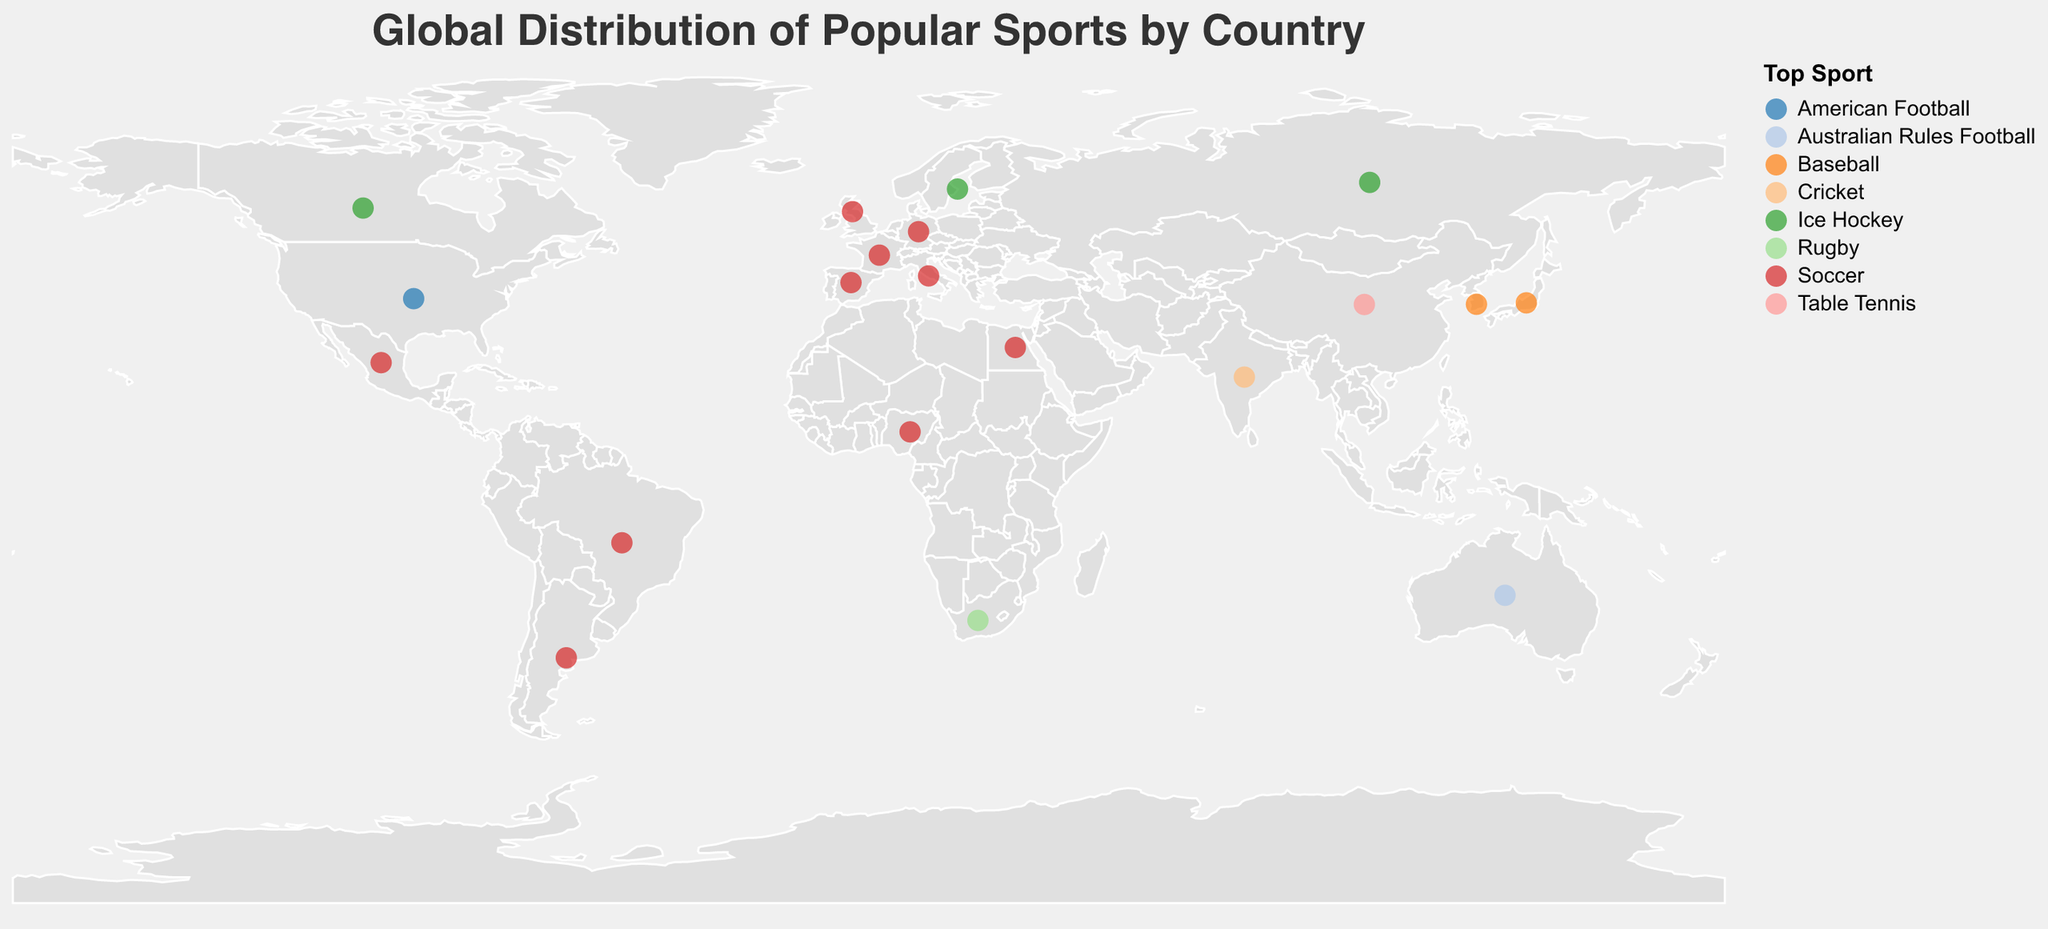Which country has Soccer listed as its top sport? Soccer being the top sport corresponds to countries with circles colored the same specific way. By hovering over the circles, we can identify these countries based on the tooltips.
Answer: Brazil, Germany, United Kingdom, France, Spain, Italy, Nigeria, Argentina, Mexico, Egypt, South Africa What are the top 3 sports in Japan? Find Japan on the map using its geographical location (latitude 36.2048, longitude 138.2529) and look at the tooltip for its top 3 sports.
Answer: Baseball, Sumo Wrestling, Soccer How many countries have Ice Hockey as their top sport? By identifying the specific color associated with Ice Hockey in the legend and counting the circles on the map that match this color, we find the countries.
Answer: 3 (Russia, Canada, Sweden) Which country has Jiu-Jitsu as one of their top 3 sports? By examining tooltips for each country or looking for unique colors representing uncommon sports, we can identify the country.
Answer: Brazil Compare the top sports between Canada and Sweden. Which sports do they share? Look at the data points for Canada and Sweden using their geographical positions and examine the tooltips for common sports.
Answer: Ice Hockey Which country in Africa has Rugby as its top sport? By identifying the color for Rugby in the legend and matching it with the country’s position in Africa, we find the required country.
Answer: South Africa What is the second most popular sport in Brazil? By locating Brazil geocentrically (latitude -14.2350, longitude -51.9253) and checking its tooltip, we identify the second most popular sport.
Answer: Volleyball Across the listed countries, how many of them have Baseball ranked in their top 3 sports? Look for instances of Baseball in the tooltips across all countries with relevant geographical locations and count them.
Answer: 4 (United States, Japan, South Korea, Mexico) Which Asian country has its top 3 sports all being unique compared to other countries? By looking at Asian countries and examining their top 3 sports in the tooltips, we identify if any country lists sports not repeated by others. Specifically check for unique sports combinations.
Answer: China (Table Tennis, Badminton, Basketball) 